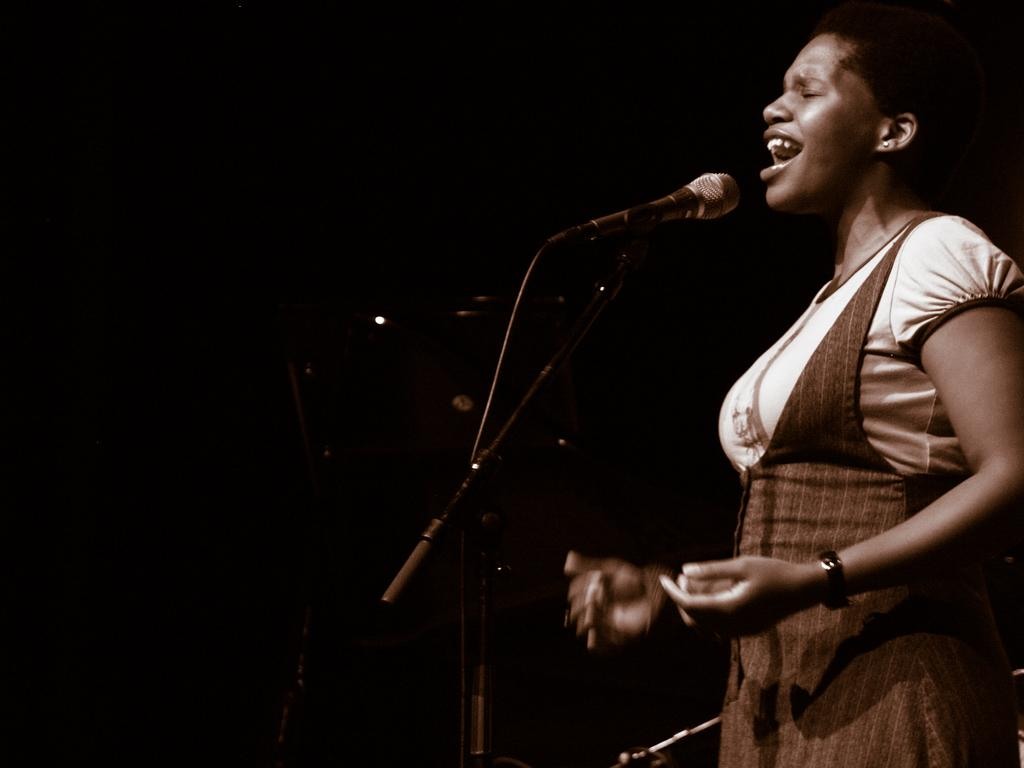Who is the main subject in the image? There is a woman in the image. What is the woman standing in front of? The woman is standing in front of a tripod. What is attached to the tripod? There is a mic on the tripod. How would you describe the lighting in the image? The background of the image is dark. What type of class is the woman teaching in the image? There is no indication in the image that the woman is teaching a class. 